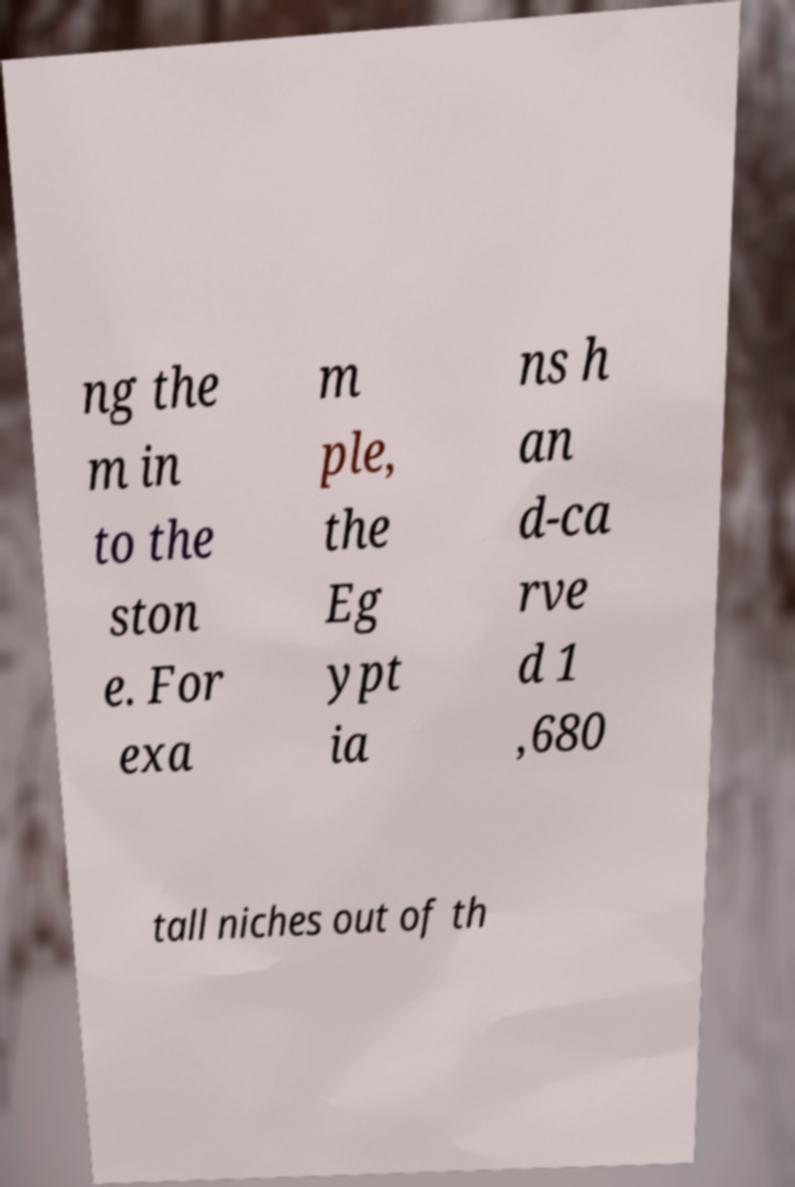Please identify and transcribe the text found in this image. ng the m in to the ston e. For exa m ple, the Eg ypt ia ns h an d-ca rve d 1 ,680 tall niches out of th 